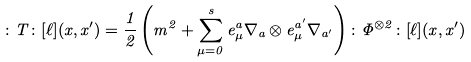<formula> <loc_0><loc_0><loc_500><loc_500>\colon T \colon [ \ell ] ( x , x ^ { \prime } ) = \frac { 1 } { 2 } \left ( m ^ { 2 } + \sum _ { \mu = 0 } ^ { s } e _ { \mu } ^ { a } \nabla _ { a } \otimes e _ { \mu } ^ { a ^ { \prime } } \nabla _ { a ^ { \prime } } \right ) \colon \Phi ^ { \otimes 2 } \colon [ \ell ] ( x , x ^ { \prime } )</formula> 